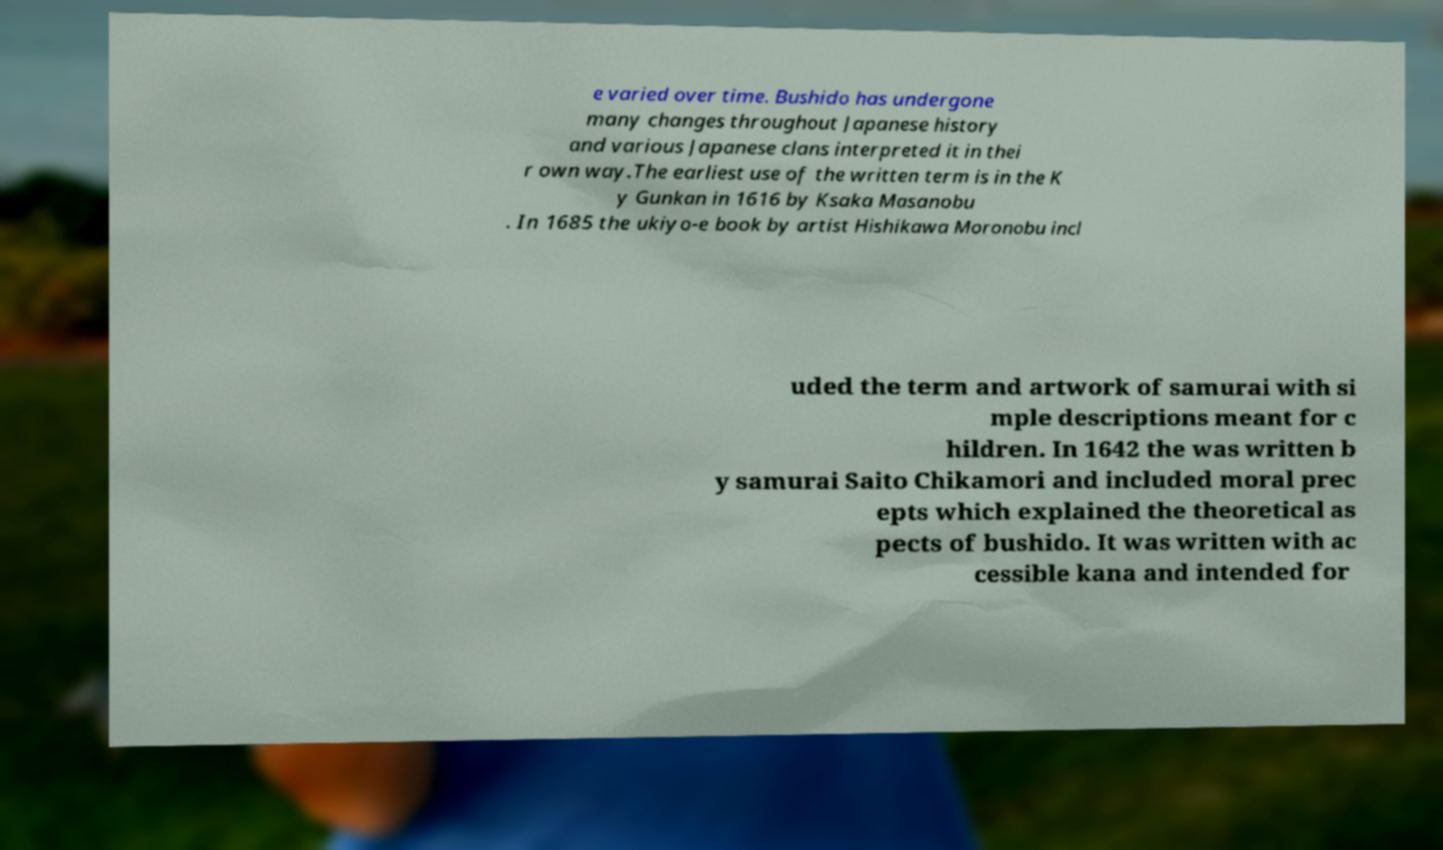Can you read and provide the text displayed in the image?This photo seems to have some interesting text. Can you extract and type it out for me? e varied over time. Bushido has undergone many changes throughout Japanese history and various Japanese clans interpreted it in thei r own way.The earliest use of the written term is in the K y Gunkan in 1616 by Ksaka Masanobu . In 1685 the ukiyo-e book by artist Hishikawa Moronobu incl uded the term and artwork of samurai with si mple descriptions meant for c hildren. In 1642 the was written b y samurai Saito Chikamori and included moral prec epts which explained the theoretical as pects of bushido. It was written with ac cessible kana and intended for 